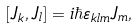Convert formula to latex. <formula><loc_0><loc_0><loc_500><loc_500>[ J _ { k } , J _ { l } ] = i \hbar { \varepsilon } _ { k l m } J _ { m } ,</formula> 